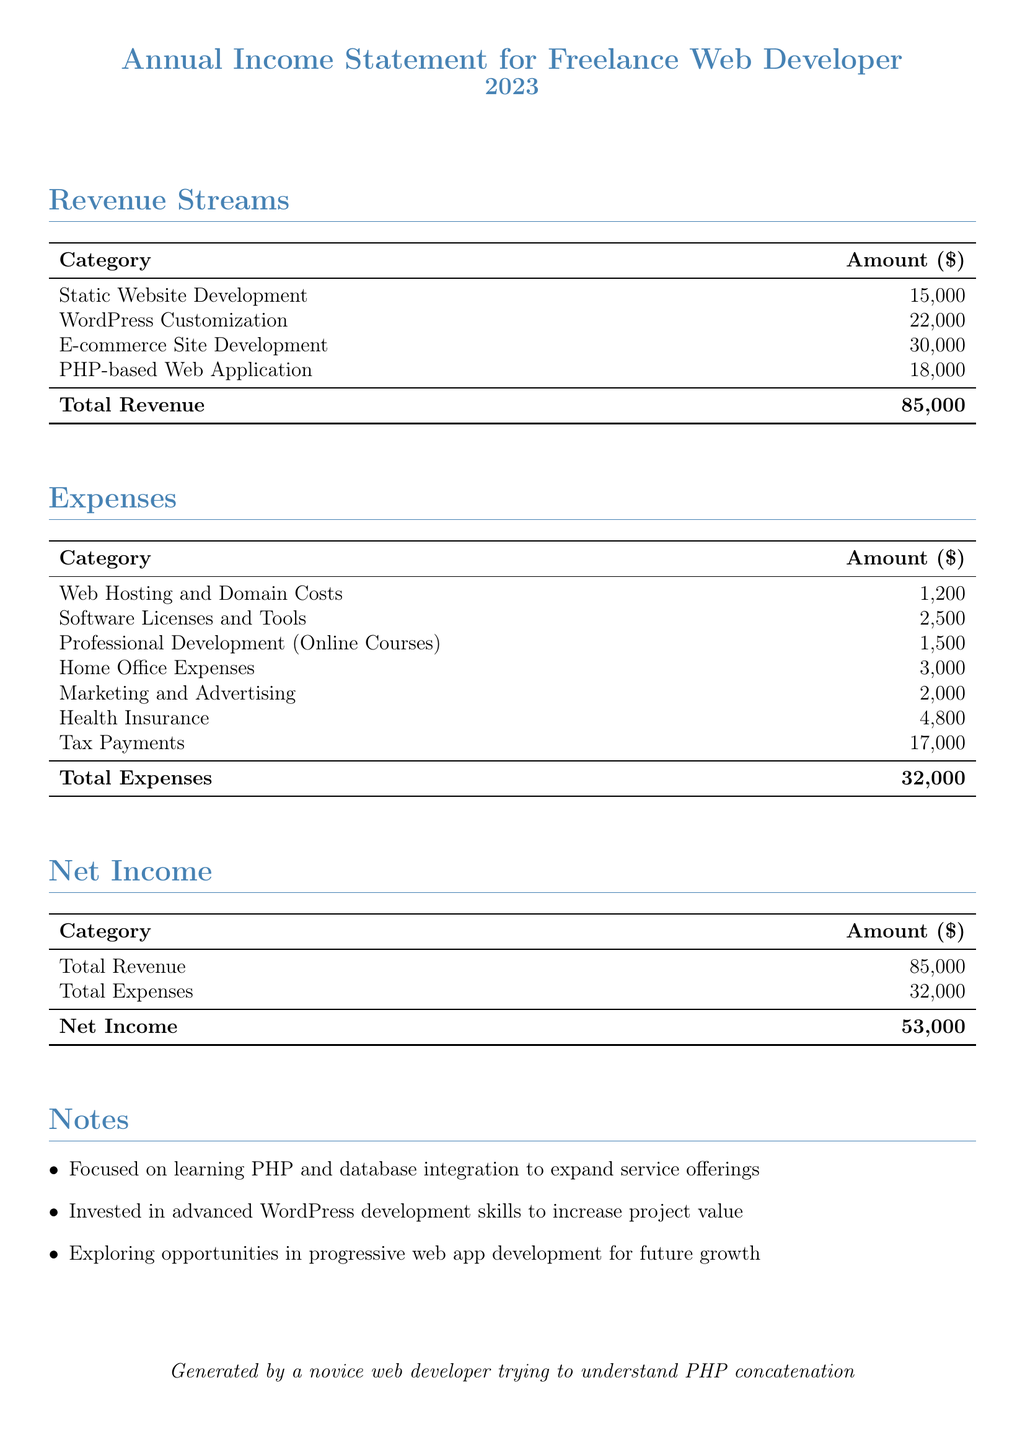What is the total revenue? The total revenue is calculated as the sum of all revenue streams listed in the document: 15000 + 22000 + 30000 + 18000 = 85000.
Answer: 85000 What was spent on Health Insurance? Health Insurance is listed as an expense in the document with the amount of 4800.
Answer: 4800 What is the category with the highest revenue? The highest revenue category is E-commerce Site Development, which amounts to 30000.
Answer: E-commerce Site Development What is the net income? The net income is calculated as total revenue minus total expenses, which is 85000 - 32000 = 53000.
Answer: 53000 What was the total amount spent on Software Licenses and Tools? The document lists Software Licenses and Tools as an expense category amounting to 2500.
Answer: 2500 What is the total expense amount? The total expenses represent the cumulative amount of all expenses in the document: 1200 + 2500 + 1500 + 3000 + 2000 + 4800 + 17000 = 32000.
Answer: 32000 How many revenue streams are listed? There are four revenue streams detailed in the revenue section of the document.
Answer: 4 What focus area is mentioned for future growth? The document mentions exploring progressive web app development for future growth.
Answer: Progressive web app development What year does this annual income statement cover? The year covered in the report is mentioned prominently in the title as 2023.
Answer: 2023 